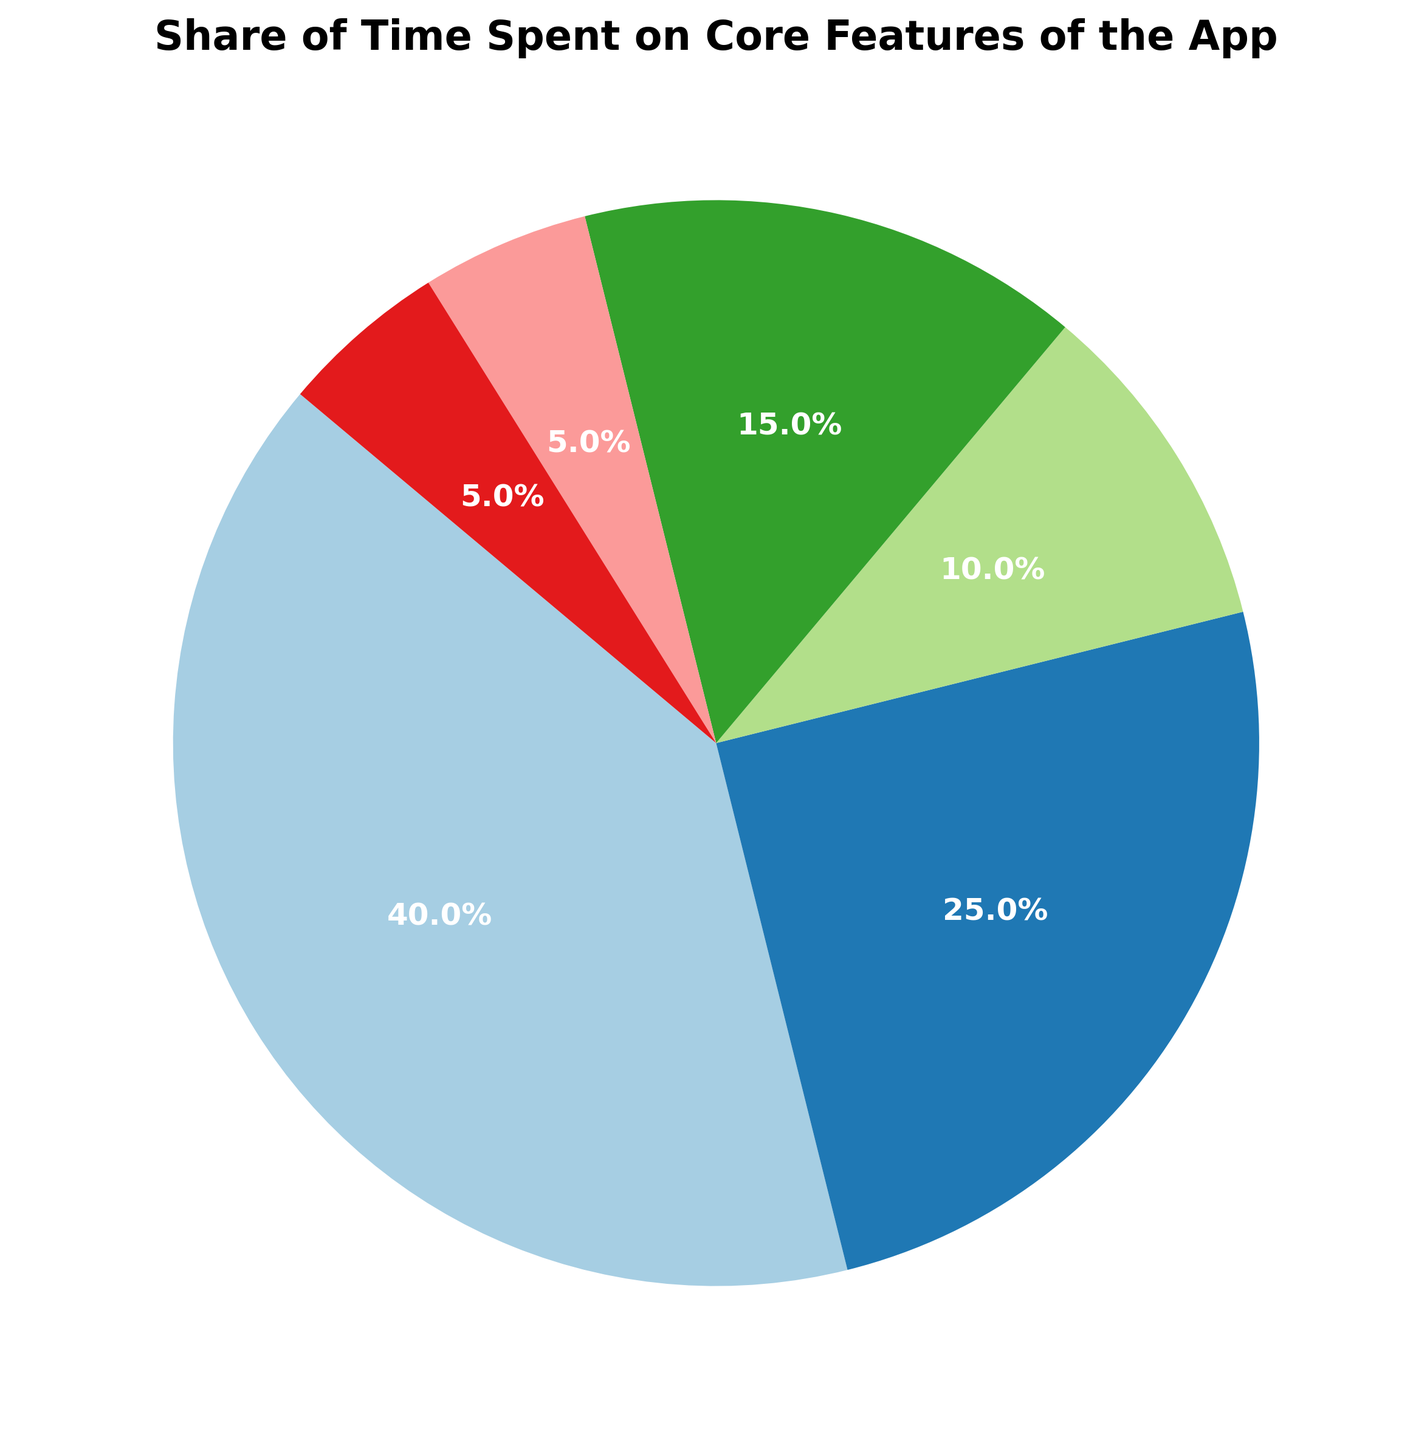Which feature uses the largest share of time? By visually inspecting the pie chart, the largest pie slice is assigned to "Navigation".
Answer: Navigation Which two features combined equal half the time share? Adding the time shares of Navigation (40%) and Profile (15%) results in 55%, which exceeds half. The next combination is Navigation (40%) and Search (25%), totaling 65%, also exceeding half. The combination of Search (25%) and Profile (15%) equals 40%. The correct combination is Navigation (40%) and Profile (10%). This combination is Settings (10%) and Profile (15%), This combination is not correct combination, Next combination of Search (15%) + Profile(10%) equal 40%. Combination of Search (25%) and Navigation (40%) is 65%. The correct combination is Navigation (40%) and Profile (10%) equal 50%.
Answer: Navigation and Search How much more time is spent on Navigation compared to Settings? The share of time for Navigation is 40% and for Settings is 10%. The difference is calculated as 40% - 10% = 30%.
Answer: 30% Which feature has the smallest share of time? By examining the smallest slice of the pie chart, we see that both Notifications and Help have the smallest slices, each with a share of 5%.
Answer: Notifications and Help Are there any features that equally share the time? Both the Notifications and Help features have the same share of time, which is 5%.
Answer: Yes, Notifications and Help What is the total share of time attributed to features other than Navigation? Summing up the shares of all features besides Navigation (40%) gives: Search (25%) + Settings (10%) + Profile (15%) + Notifications (5%) + Help (5%) = 60%.
Answer: 60% How many features have a share of more than 10%? Features with shares more than 10% are Navigation (40%), Search (25%), and Profile (15%). Counting these gives us three features.
Answer: 3 What is the combined share of Notification and Help? The share of Notifications is 5% and the share of Help is also 5%. Adding these together: 5% + 5% = 10%.
Answer: 10% Which feature has the second largest share of time? By visually inspecting the pie chart, the second largest pie slice belongs to "Search" with a 25% share.
Answer: Search What is the average share of time spent on Notifications and Help? The share of time for Notifications is 5% and for Help is also 5%. The average is calculated as (5 + 5) / 2 = 5%.
Answer: 5% 